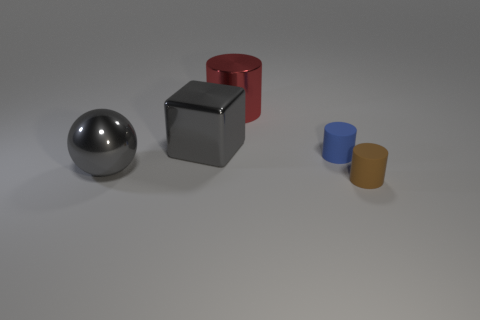Add 3 gray shiny objects. How many objects exist? 8 Subtract all small blue cylinders. How many cylinders are left? 2 Subtract 3 cylinders. How many cylinders are left? 0 Subtract all brown cylinders. How many cylinders are left? 2 Subtract all red cylinders. How many yellow spheres are left? 0 Subtract all small blue cylinders. Subtract all tiny brown rubber cylinders. How many objects are left? 3 Add 1 brown things. How many brown things are left? 2 Add 2 tiny metallic balls. How many tiny metallic balls exist? 2 Subtract 0 red balls. How many objects are left? 5 Subtract all cylinders. How many objects are left? 2 